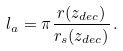<formula> <loc_0><loc_0><loc_500><loc_500>l _ { a } = \pi \frac { r ( z _ { d e c } ) } { r _ { s } ( z _ { d e c } ) } \, .</formula> 